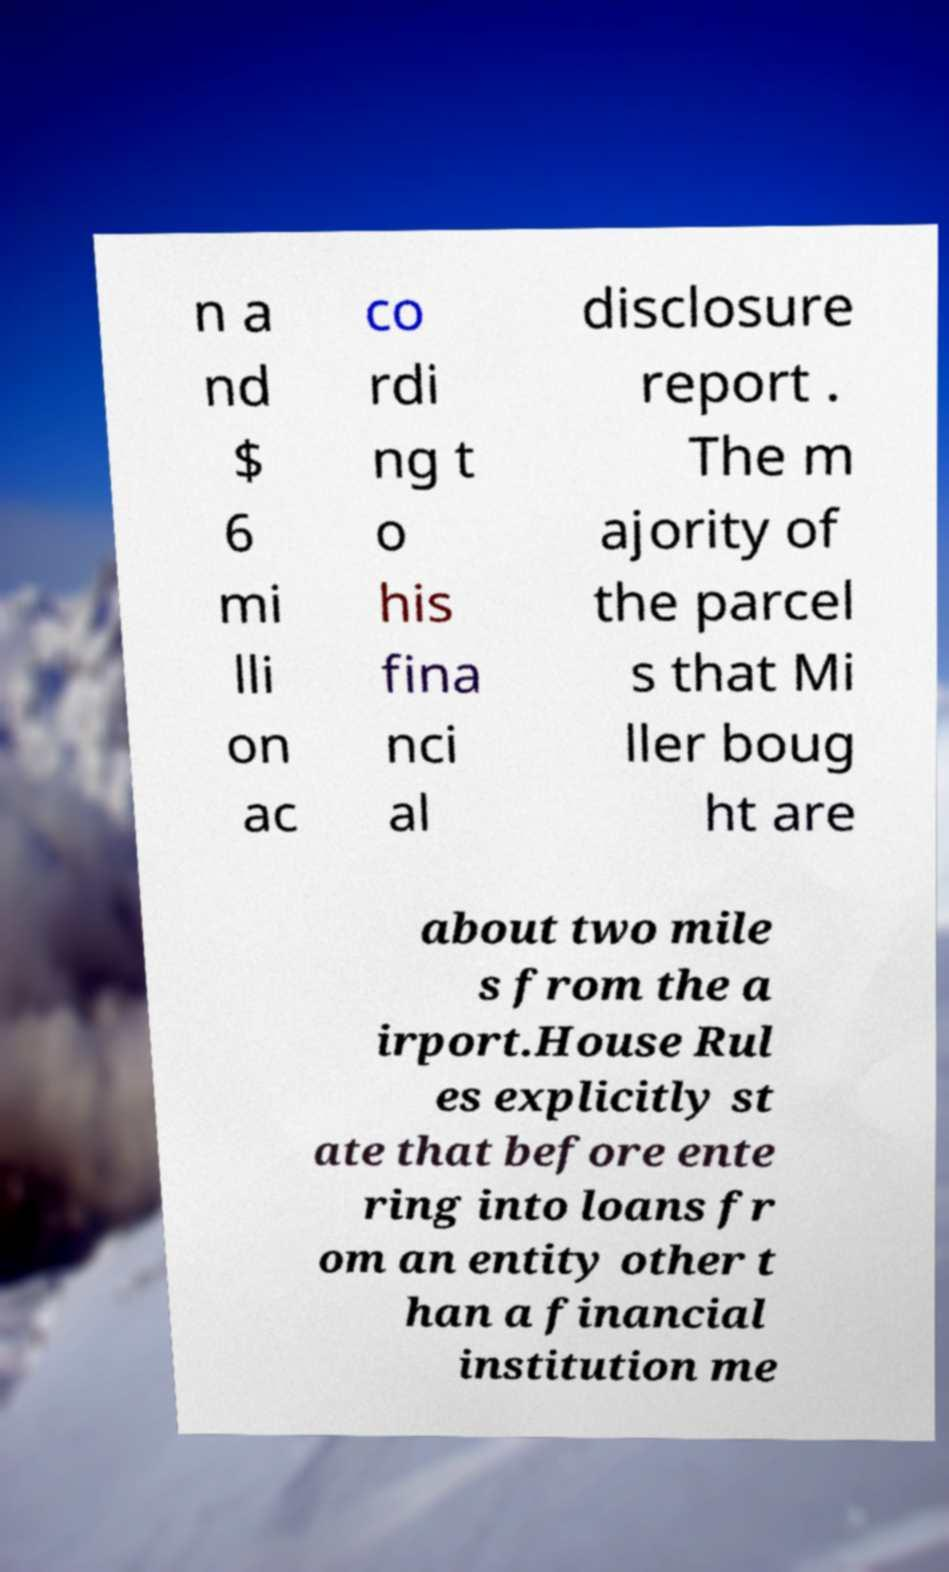What messages or text are displayed in this image? I need them in a readable, typed format. n a nd $ 6 mi lli on ac co rdi ng t o his fina nci al disclosure report . The m ajority of the parcel s that Mi ller boug ht are about two mile s from the a irport.House Rul es explicitly st ate that before ente ring into loans fr om an entity other t han a financial institution me 